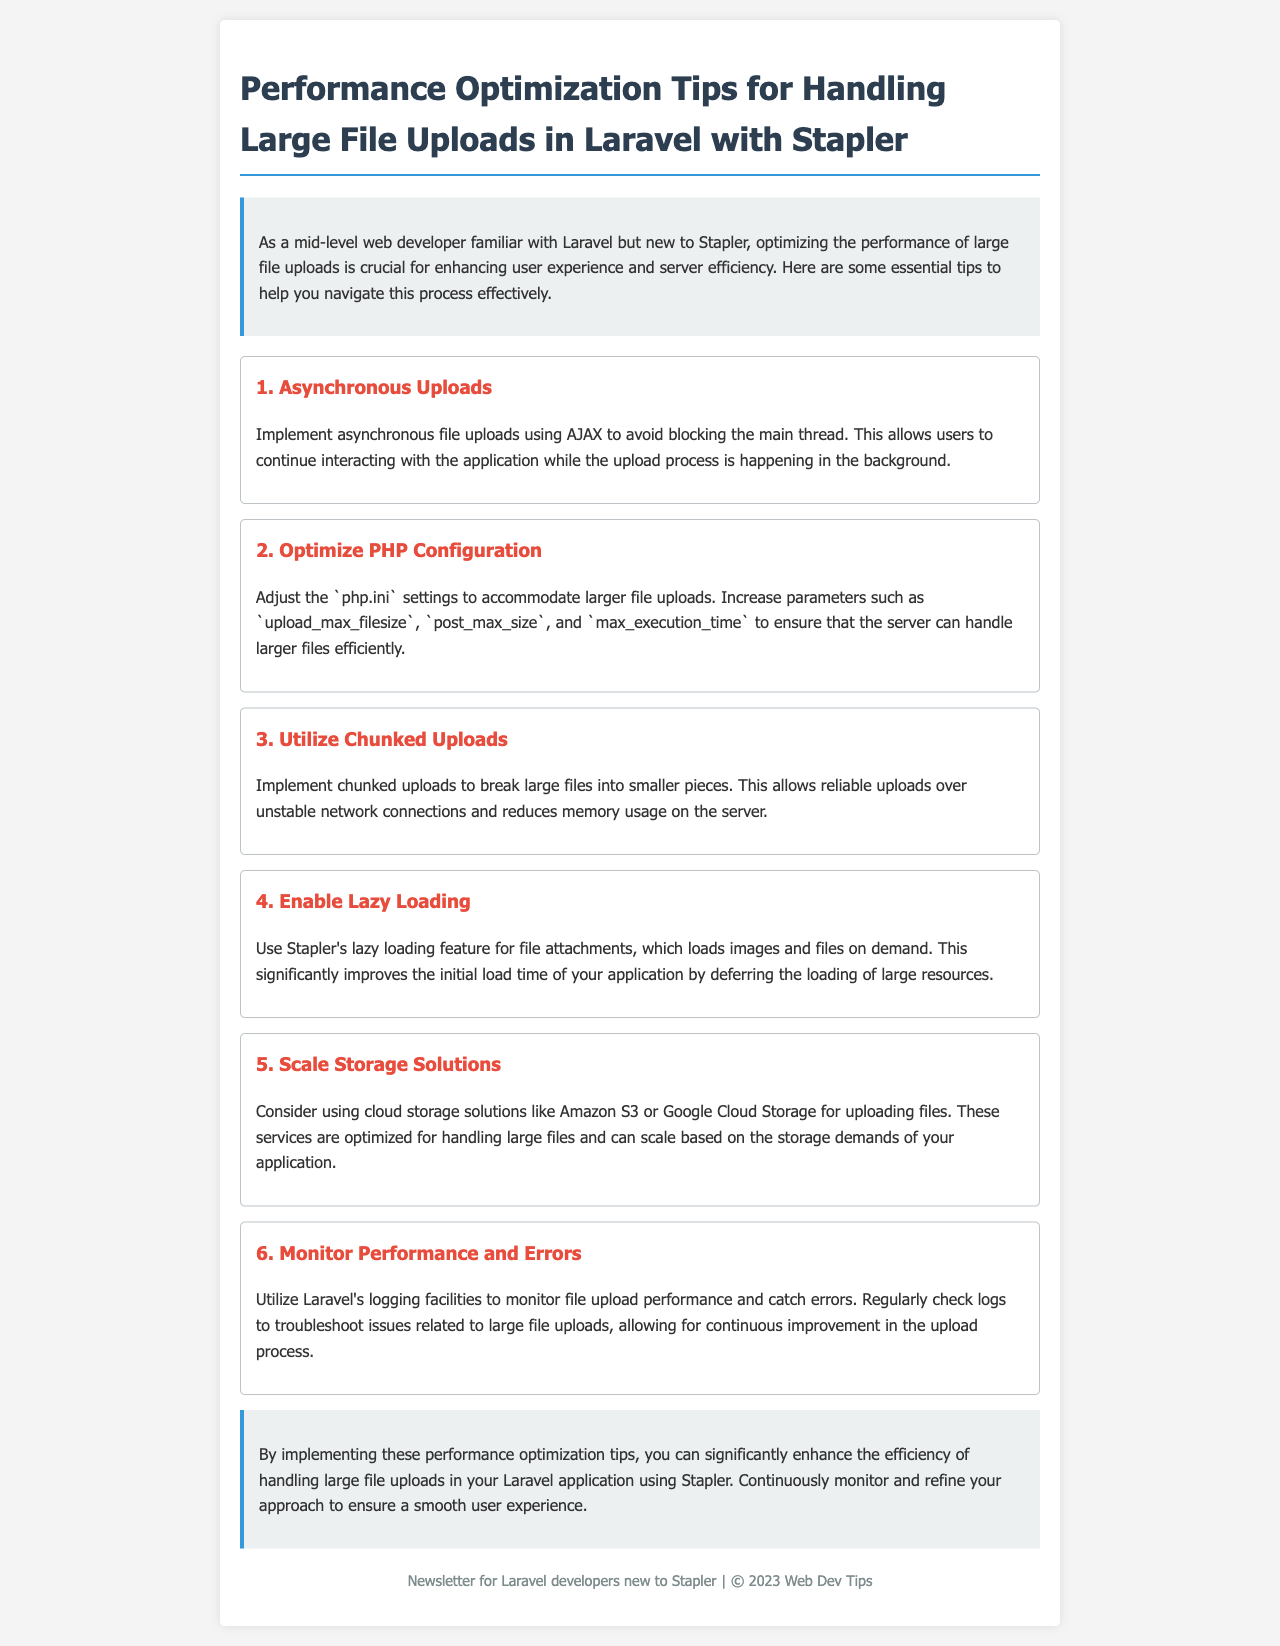What is the main topic of the newsletter? The main topic is about performance optimization tips for handling large file uploads in Laravel with Stapler.
Answer: Performance optimization tips for handling large file uploads in Laravel with Stapler How many performance tips are provided in the document? The document lists a total of six performance tips.
Answer: Six What does the first tip suggest for file uploads? The first tip suggests implementing asynchronous file uploads using AJAX.
Answer: Asynchronous uploads What is the recommended cloud storage solution mentioned? The document recommends using Amazon S3 or Google Cloud Storage for uploading files.
Answer: Amazon S3 or Google Cloud Storage What feature does Stapler offer to improve load times? Stapler's lazy loading feature improves load times by loading files on demand.
Answer: Lazy loading What is the purpose of monitoring performance and errors? The purpose is to troubleshoot issues related to large file uploads for continuous improvement.
Answer: Troubleshoot issues for continuous improvement 